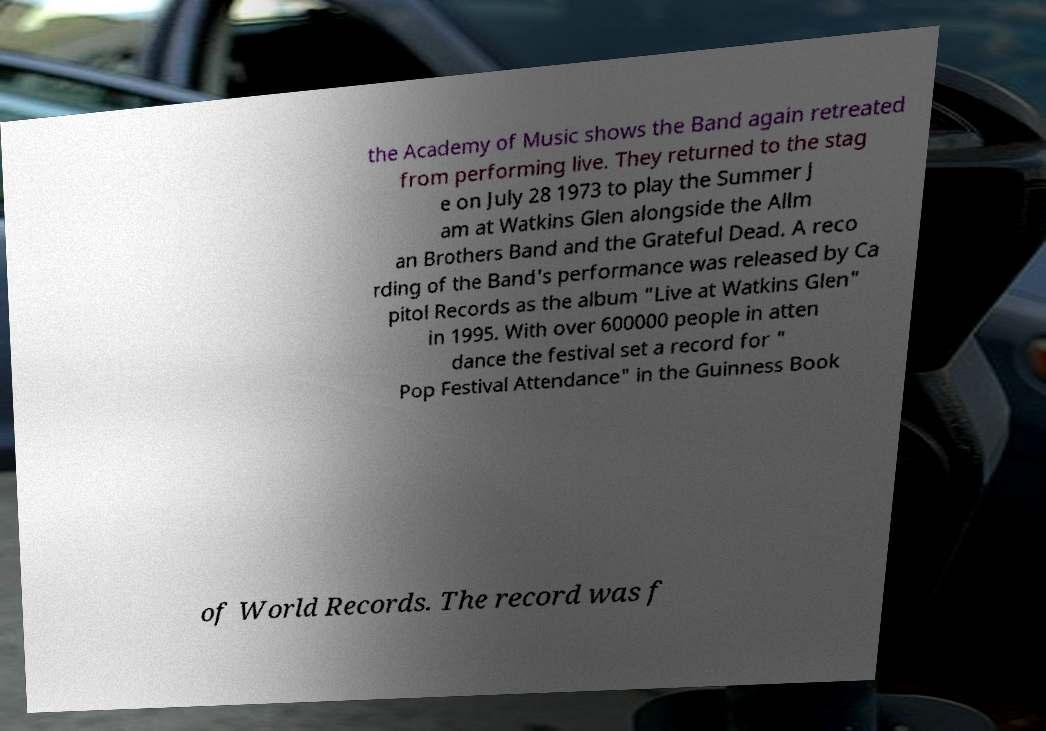Please identify and transcribe the text found in this image. the Academy of Music shows the Band again retreated from performing live. They returned to the stag e on July 28 1973 to play the Summer J am at Watkins Glen alongside the Allm an Brothers Band and the Grateful Dead. A reco rding of the Band's performance was released by Ca pitol Records as the album "Live at Watkins Glen" in 1995. With over 600000 people in atten dance the festival set a record for " Pop Festival Attendance" in the Guinness Book of World Records. The record was f 